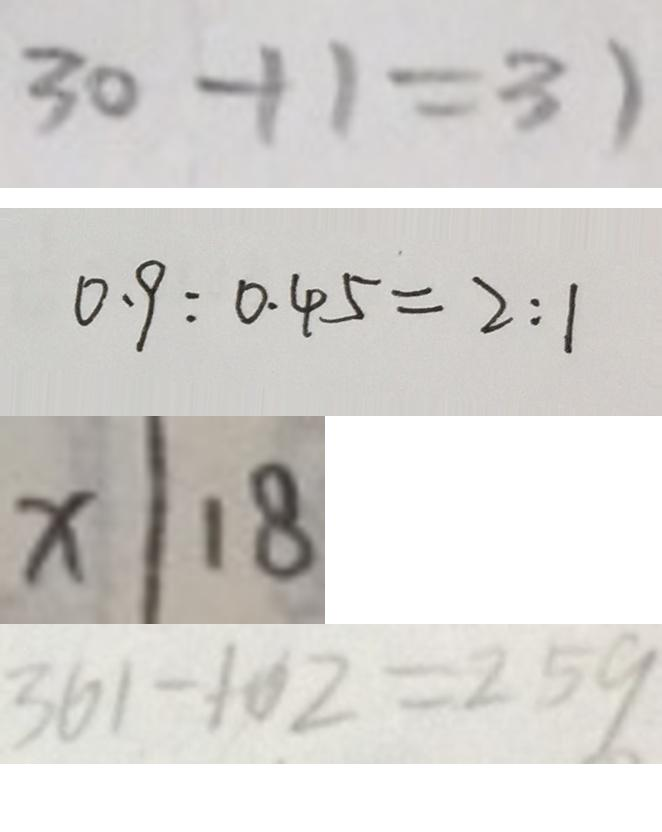Convert formula to latex. <formula><loc_0><loc_0><loc_500><loc_500>3 0 + 1 = 3 1 
 0 . 9 : 0 . 4 5 = 2 : 1 
 x \vert 1 8 
 3 6 1 - 1 0 2 = 2 5 9</formula> 